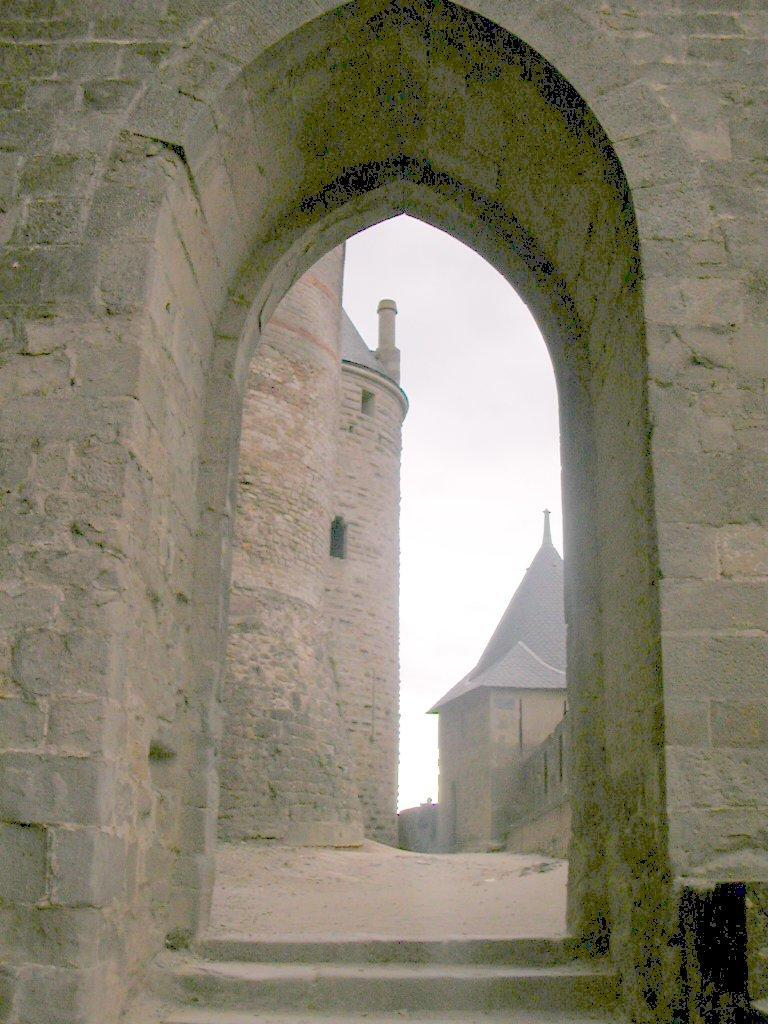What type of structure is present in the image? There is an arch in the image. What can be seen through the arch? Buildings are visible through the arch. What type of surface is visible in the image? There is ground visible in the image. What is visible in the sky in the image? There are clouds in the sky. What type of door can be seen leading to the buildings in the image? There is no door present in the image; it features an arch through which buildings can be seen. What emotion is the ground feeling in the image? The ground is an inanimate object and does not have emotions like regret. 